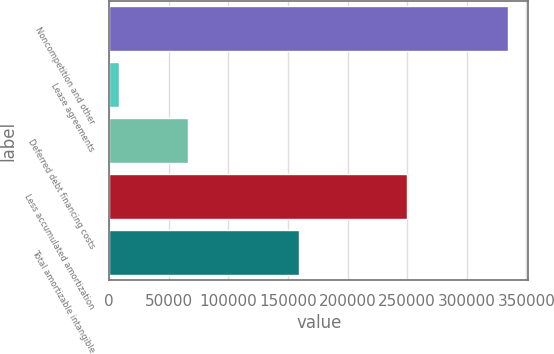Convert chart. <chart><loc_0><loc_0><loc_500><loc_500><bar_chart><fcel>Noncompetition and other<fcel>Lease agreements<fcel>Deferred debt financing costs<fcel>Less accumulated amortization<fcel>Total amortizable intangible<nl><fcel>335012<fcel>8081<fcel>66011<fcel>249613<fcel>159491<nl></chart> 